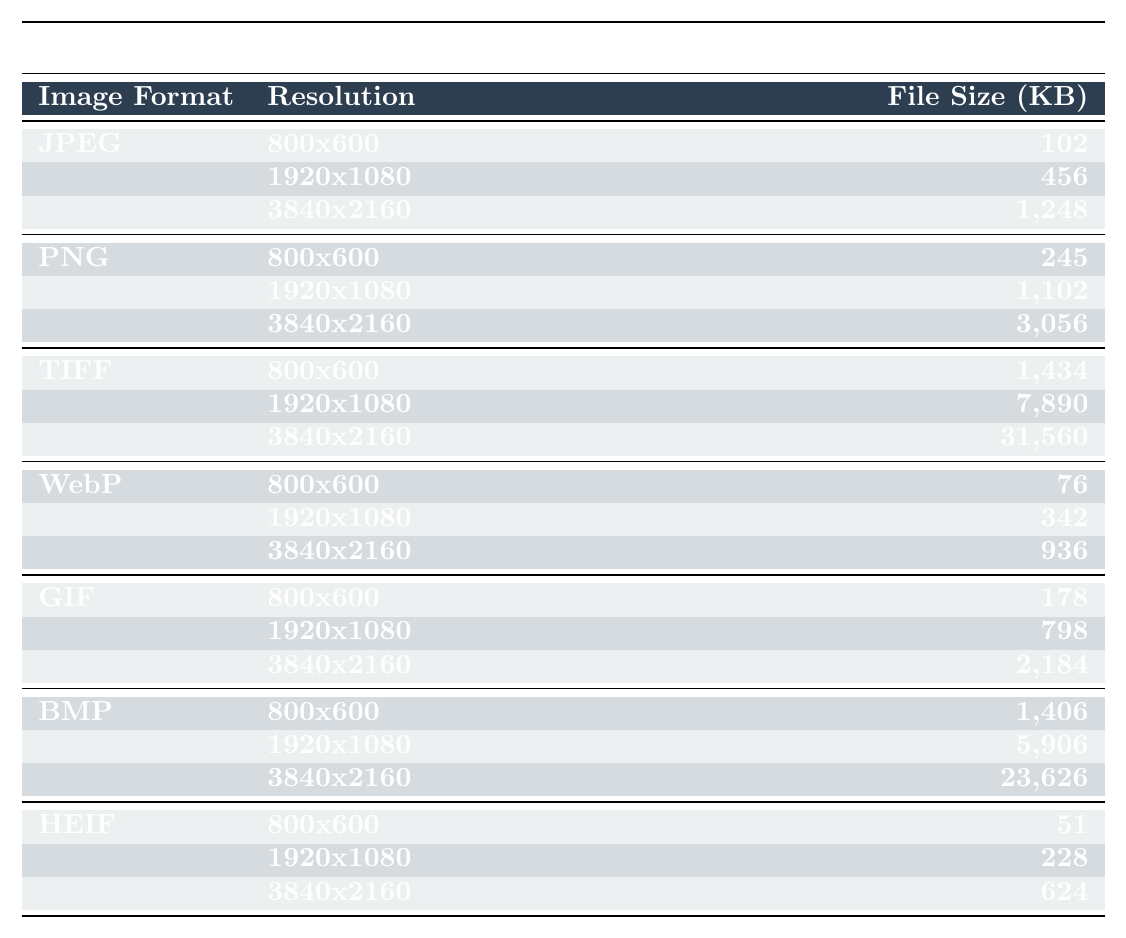What is the file size of a JPEG image at a resolution of 1920x1080? The table shows that the file size for a JPEG image with a resolution of 1920x1080 is 456 KB.
Answer: 456 KB Which image format has the smallest file size at a resolution of 800x600? From the table, the HEIF format has the smallest file size at 51 KB compared to others.
Answer: HEIF What is the file size difference between the PNG and TIFF formats at a resolution of 3840x2160? The file size for PNG at 3840x2160 is 3056 KB, while for TIFF it is 31560 KB. The difference is 31560 - 3056 = 28404 KB.
Answer: 28404 KB Is the file size of a WebP image at 1920x1080 larger than that of a GIF image at the same resolution? The table shows that the WebP file size is 342 KB, and the GIF file size is 798 KB. Therefore, the assertion is false.
Answer: No What is the average file size of all formats at the resolution of 800x600? The file sizes for 800x600 are: JPEG (102), PNG (245), TIFF (1434), WebP (76), GIF (178), BMP (1406), and HEIF (51). Summing these gives 102 + 245 + 1434 + 76 + 178 + 1406 + 51 = 2592 KB. There are 7 formats, so the average is 2592 / 7 = 370.29 KB.
Answer: 370.29 KB At 3840x2160 resolution, which image format has the largest file size? The table indicates that the file size for TIFF at this resolution is 31560 KB, which is larger than all other formats listed.
Answer: TIFF What is the total file size of the JPEG images across all resolutions? The file sizes for JPEG are 102 KB (800x600), 456 KB (1920x1080), and 1248 KB (3840x2160). Summing these gives 102 + 456 + 1248 = 1806 KB.
Answer: 1806 KB Which format shows the highest increase in file size when comparing its 800x600 resolution to 3840x2160 resolution? We calculate the increases for each format: JPEG (1248 - 102 = 1146), PNG (3056 - 245 = 2811), TIFF (31560 - 1434 = 30126), WebP (936 - 76 = 860), GIF (2184 - 178 = 2006), BMP (23626 - 1406 = 22220), HEIF (624 - 51 = 573). The largest increase is from the TIFF format at 30126 KB.
Answer: TIFF Does the file size of the BMP format at 1920x1080 exceed 6000 KB? The table lists the BMP file size at 1920x1080 as 5906 KB, which does not exceed 6000 KB, thus the statement is false.
Answer: No What is the cumulative file size for the WebP images at 800x600 and 1920x1080 resolutions? The file sizes for WebP are 76 KB (800x600) and 342 KB (1920x1080), summing these gives 76 + 342 = 418 KB.
Answer: 418 KB 